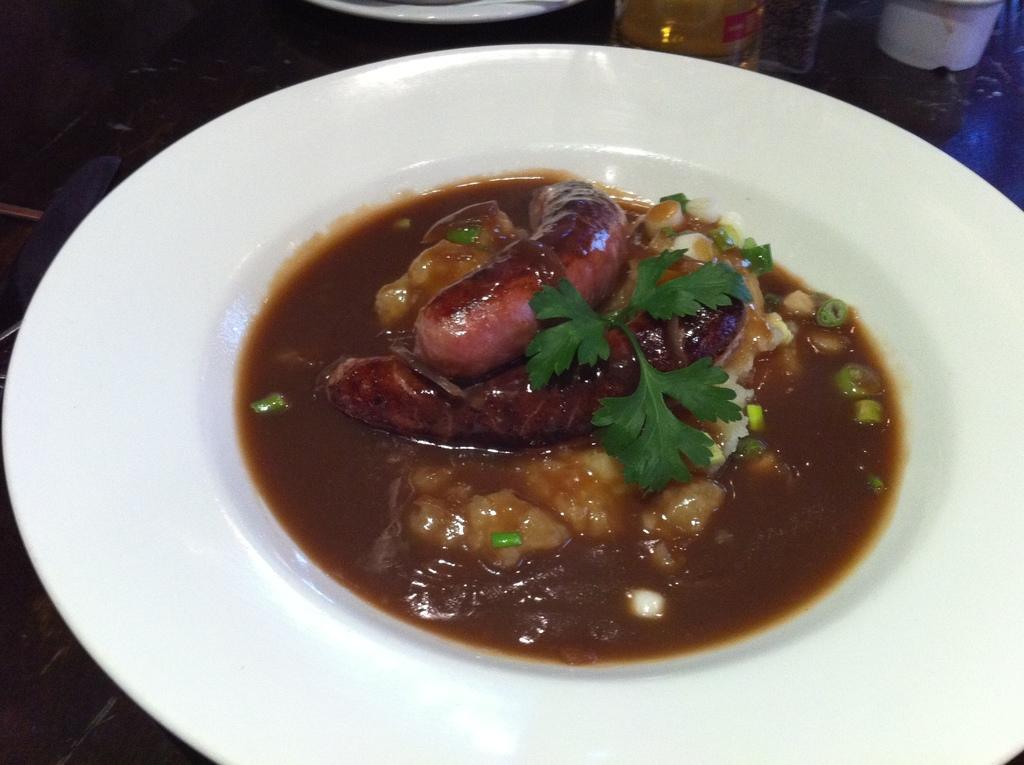In one or two sentences, can you explain what this image depicts? In this image at the bottom there is a table, on the table there is one plate. In that plate there is some food, and in the background there are some objects. 